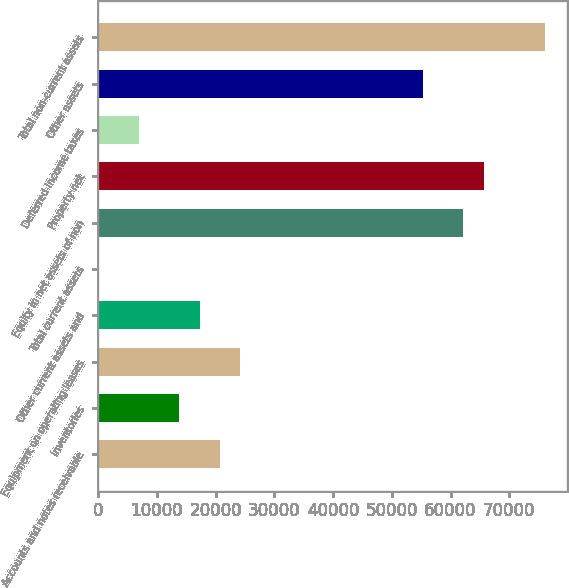<chart> <loc_0><loc_0><loc_500><loc_500><bar_chart><fcel>Accounts and notes receivable<fcel>Inventories<fcel>Equipment on operating leases<fcel>Other current assets and<fcel>Total current assets<fcel>Equity in net assets of non<fcel>Property net<fcel>Deferred income taxes<fcel>Other assets<fcel>Total non-current assets<nl><fcel>20737.4<fcel>13829.6<fcel>24191.3<fcel>17283.5<fcel>14<fcel>62184.2<fcel>65638.1<fcel>6921.8<fcel>55276.4<fcel>75999.8<nl></chart> 